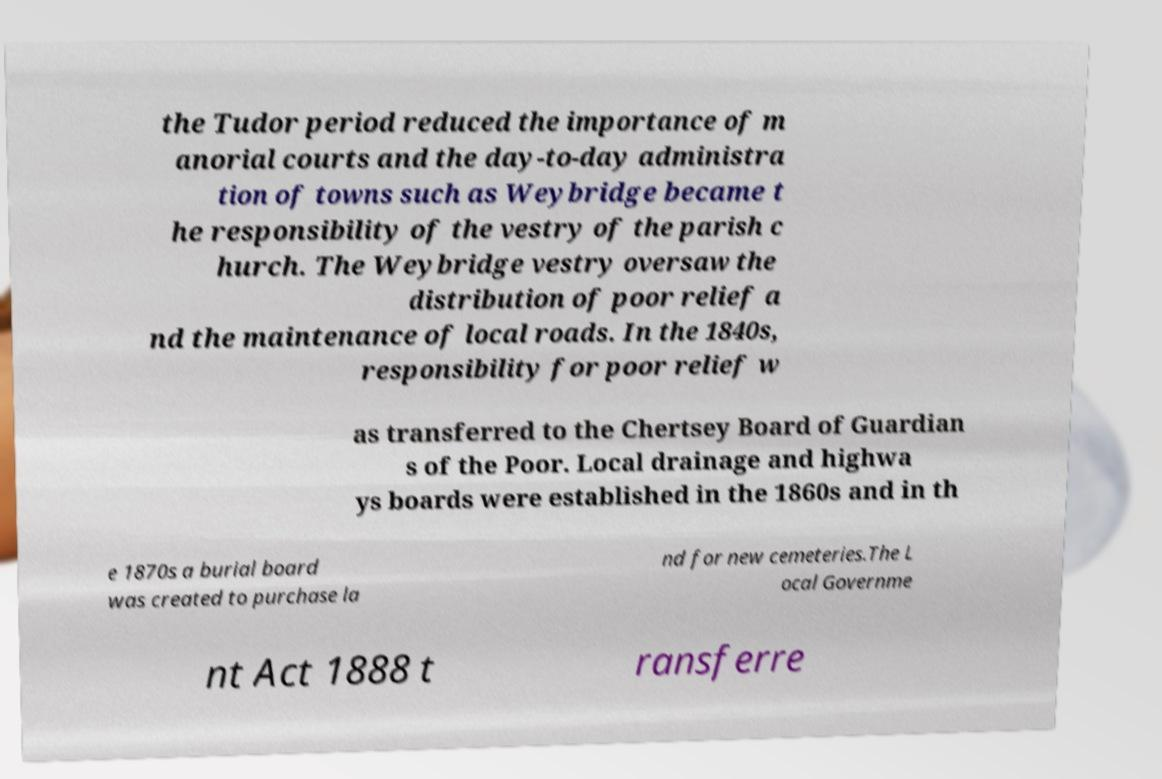Can you accurately transcribe the text from the provided image for me? the Tudor period reduced the importance of m anorial courts and the day-to-day administra tion of towns such as Weybridge became t he responsibility of the vestry of the parish c hurch. The Weybridge vestry oversaw the distribution of poor relief a nd the maintenance of local roads. In the 1840s, responsibility for poor relief w as transferred to the Chertsey Board of Guardian s of the Poor. Local drainage and highwa ys boards were established in the 1860s and in th e 1870s a burial board was created to purchase la nd for new cemeteries.The L ocal Governme nt Act 1888 t ransferre 